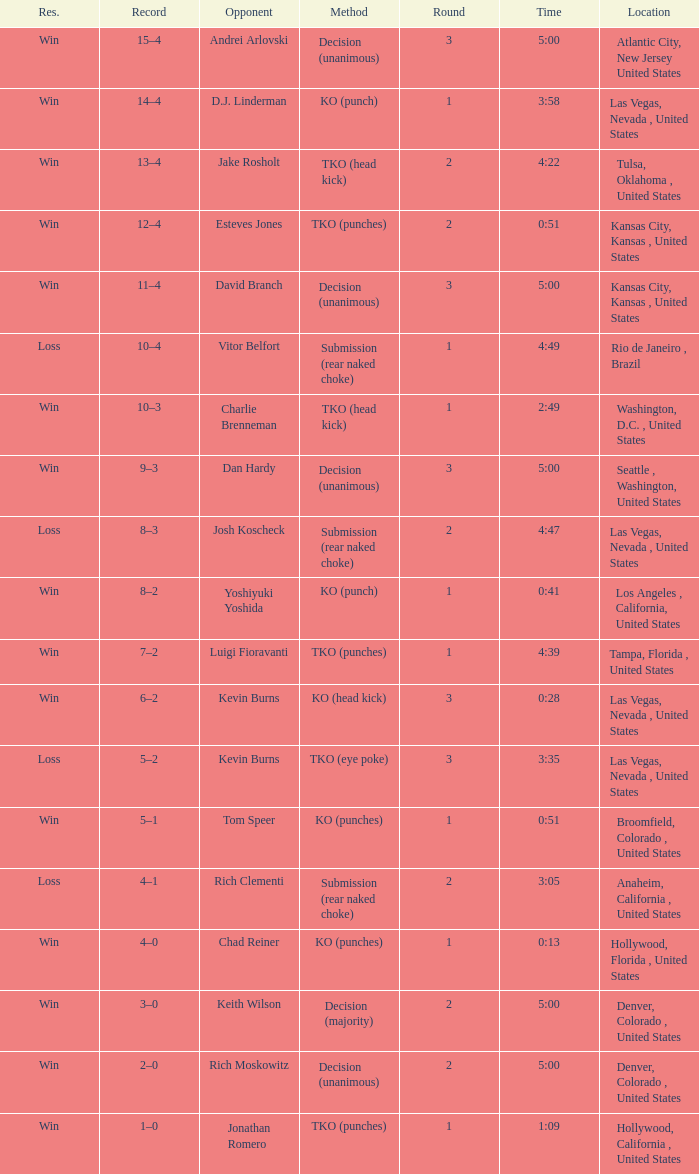With a time of 4:39, what is the maximum round number possible? 1.0. I'm looking to parse the entire table for insights. Could you assist me with that? {'header': ['Res.', 'Record', 'Opponent', 'Method', 'Round', 'Time', 'Location'], 'rows': [['Win', '15–4', 'Andrei Arlovski', 'Decision (unanimous)', '3', '5:00', 'Atlantic City, New Jersey United States'], ['Win', '14–4', 'D.J. Linderman', 'KO (punch)', '1', '3:58', 'Las Vegas, Nevada , United States'], ['Win', '13–4', 'Jake Rosholt', 'TKO (head kick)', '2', '4:22', 'Tulsa, Oklahoma , United States'], ['Win', '12–4', 'Esteves Jones', 'TKO (punches)', '2', '0:51', 'Kansas City, Kansas , United States'], ['Win', '11–4', 'David Branch', 'Decision (unanimous)', '3', '5:00', 'Kansas City, Kansas , United States'], ['Loss', '10–4', 'Vitor Belfort', 'Submission (rear naked choke)', '1', '4:49', 'Rio de Janeiro , Brazil'], ['Win', '10–3', 'Charlie Brenneman', 'TKO (head kick)', '1', '2:49', 'Washington, D.C. , United States'], ['Win', '9–3', 'Dan Hardy', 'Decision (unanimous)', '3', '5:00', 'Seattle , Washington, United States'], ['Loss', '8–3', 'Josh Koscheck', 'Submission (rear naked choke)', '2', '4:47', 'Las Vegas, Nevada , United States'], ['Win', '8–2', 'Yoshiyuki Yoshida', 'KO (punch)', '1', '0:41', 'Los Angeles , California, United States'], ['Win', '7–2', 'Luigi Fioravanti', 'TKO (punches)', '1', '4:39', 'Tampa, Florida , United States'], ['Win', '6–2', 'Kevin Burns', 'KO (head kick)', '3', '0:28', 'Las Vegas, Nevada , United States'], ['Loss', '5–2', 'Kevin Burns', 'TKO (eye poke)', '3', '3:35', 'Las Vegas, Nevada , United States'], ['Win', '5–1', 'Tom Speer', 'KO (punches)', '1', '0:51', 'Broomfield, Colorado , United States'], ['Loss', '4–1', 'Rich Clementi', 'Submission (rear naked choke)', '2', '3:05', 'Anaheim, California , United States'], ['Win', '4–0', 'Chad Reiner', 'KO (punches)', '1', '0:13', 'Hollywood, Florida , United States'], ['Win', '3–0', 'Keith Wilson', 'Decision (majority)', '2', '5:00', 'Denver, Colorado , United States'], ['Win', '2–0', 'Rich Moskowitz', 'Decision (unanimous)', '2', '5:00', 'Denver, Colorado , United States'], ['Win', '1–0', 'Jonathan Romero', 'TKO (punches)', '1', '1:09', 'Hollywood, California , United States']]} 